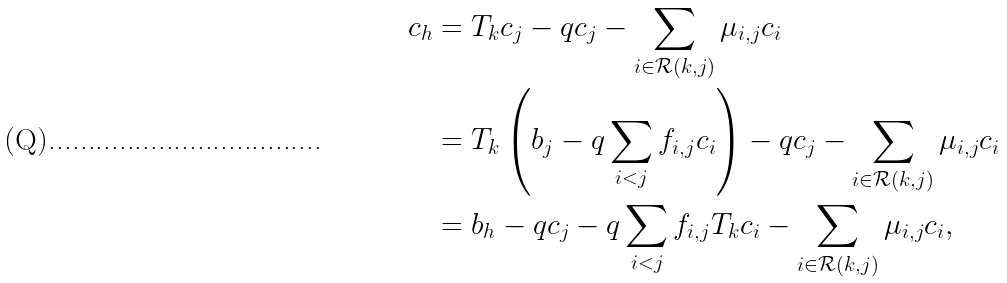Convert formula to latex. <formula><loc_0><loc_0><loc_500><loc_500>c _ { h } & = T _ { k } c _ { j } - q c _ { j } - \sum _ { i \in \mathcal { R } ( k , j ) } \mu _ { i , j } c _ { i } \\ & = T _ { k } \left ( b _ { j } - q \sum _ { i < j } f _ { i , j } c _ { i } \right ) - q c _ { j } - \sum _ { i \in \mathcal { R } ( k , j ) } \mu _ { i , j } c _ { i } \\ & = b _ { h } - q c _ { j } - q \sum _ { i < j } f _ { i , j } T _ { k } c _ { i } - \sum _ { i \in \mathcal { R } ( k , j ) } \mu _ { i , j } c _ { i } ,</formula> 